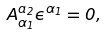Convert formula to latex. <formula><loc_0><loc_0><loc_500><loc_500>A _ { \alpha _ { 1 } } ^ { a _ { 2 } } \epsilon ^ { \alpha _ { 1 } } = 0 ,</formula> 